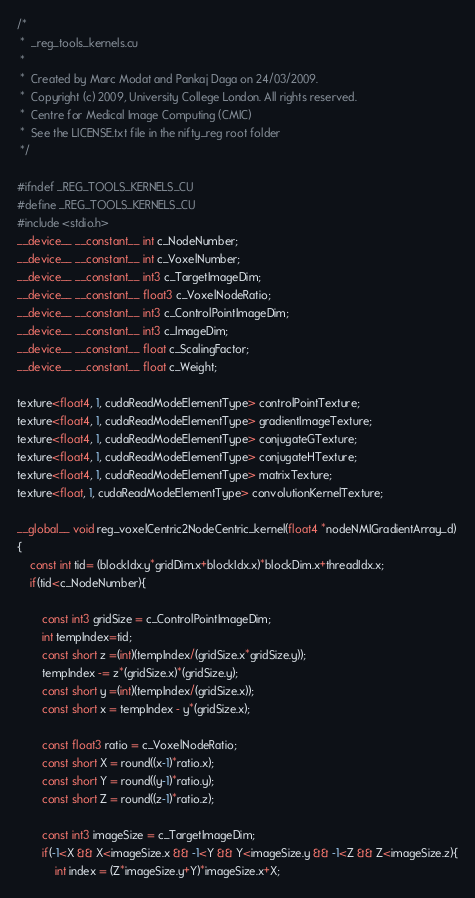<code> <loc_0><loc_0><loc_500><loc_500><_Cuda_>/*
 *  _reg_tools_kernels.cu
 *
 *  Created by Marc Modat and Pankaj Daga on 24/03/2009.
 *  Copyright (c) 2009, University College London. All rights reserved.
 *  Centre for Medical Image Computing (CMIC)
 *  See the LICENSE.txt file in the nifty_reg root folder
 */

#ifndef _REG_TOOLS_KERNELS_CU
#define _REG_TOOLS_KERNELS_CU
#include <stdio.h>
__device__ __constant__ int c_NodeNumber;
__device__ __constant__ int c_VoxelNumber;
__device__ __constant__ int3 c_TargetImageDim;
__device__ __constant__ float3 c_VoxelNodeRatio;
__device__ __constant__ int3 c_ControlPointImageDim;
__device__ __constant__ int3 c_ImageDim;
__device__ __constant__ float c_ScalingFactor;
__device__ __constant__ float c_Weight;

texture<float4, 1, cudaReadModeElementType> controlPointTexture;
texture<float4, 1, cudaReadModeElementType> gradientImageTexture;
texture<float4, 1, cudaReadModeElementType> conjugateGTexture;
texture<float4, 1, cudaReadModeElementType> conjugateHTexture;
texture<float4, 1, cudaReadModeElementType> matrixTexture;
texture<float, 1, cudaReadModeElementType> convolutionKernelTexture;

__global__ void reg_voxelCentric2NodeCentric_kernel(float4 *nodeNMIGradientArray_d)
{
    const int tid= (blockIdx.y*gridDim.x+blockIdx.x)*blockDim.x+threadIdx.x;
    if(tid<c_NodeNumber){

        const int3 gridSize = c_ControlPointImageDim;
        int tempIndex=tid;
        const short z =(int)(tempIndex/(gridSize.x*gridSize.y));
        tempIndex -= z*(gridSize.x)*(gridSize.y);
        const short y =(int)(tempIndex/(gridSize.x));
        const short x = tempIndex - y*(gridSize.x);

        const float3 ratio = c_VoxelNodeRatio;
        const short X = round((x-1)*ratio.x);
        const short Y = round((y-1)*ratio.y);
        const short Z = round((z-1)*ratio.z);

        const int3 imageSize = c_TargetImageDim;
        if(-1<X && X<imageSize.x && -1<Y && Y<imageSize.y && -1<Z && Z<imageSize.z){
            int index = (Z*imageSize.y+Y)*imageSize.x+X;</code> 